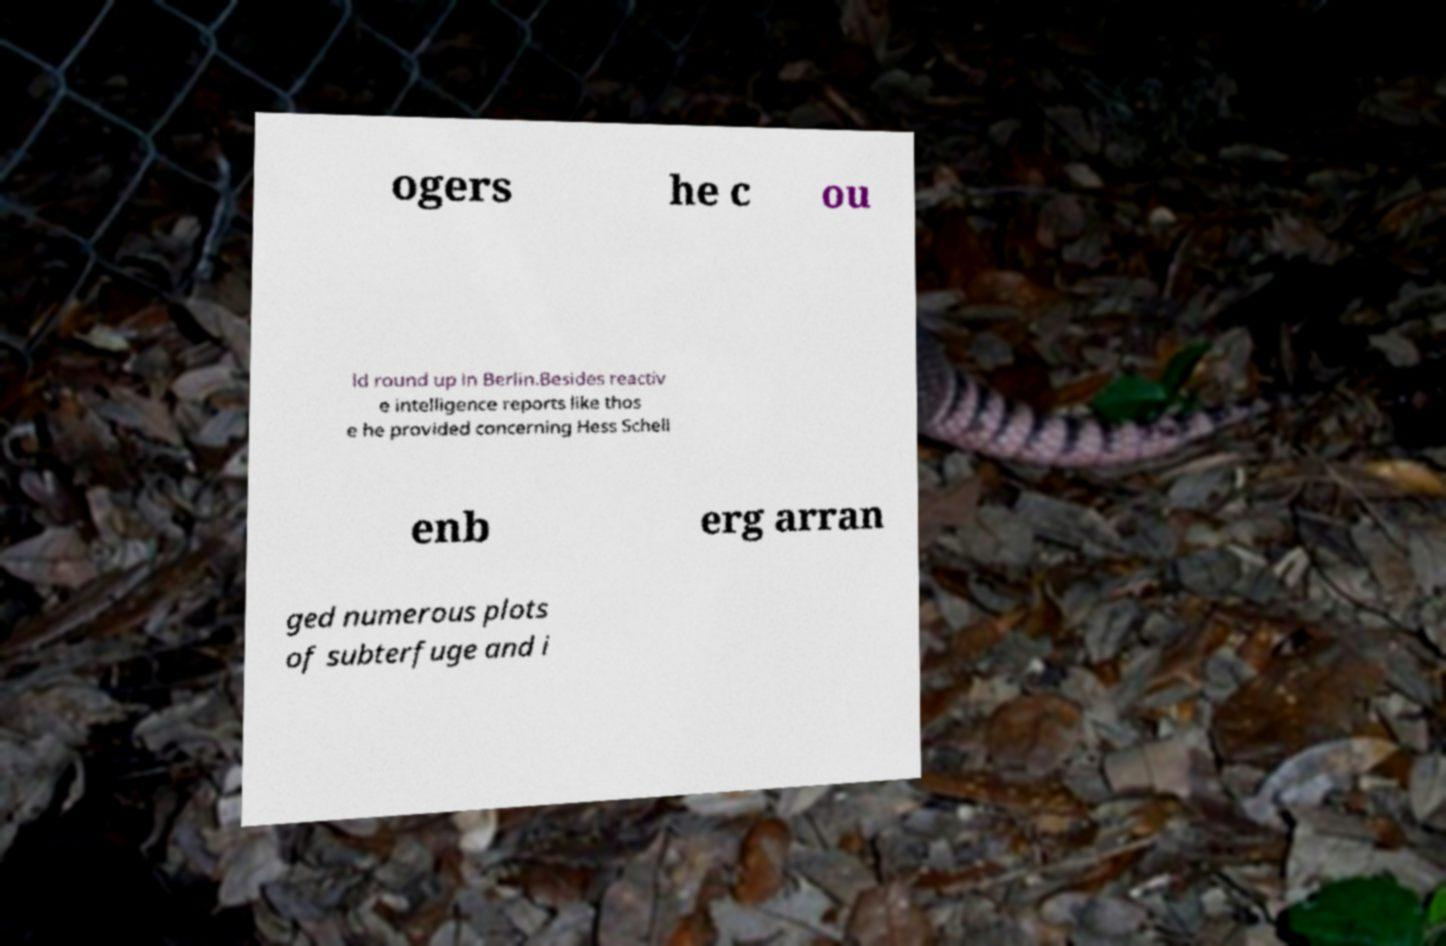There's text embedded in this image that I need extracted. Can you transcribe it verbatim? ogers he c ou ld round up in Berlin.Besides reactiv e intelligence reports like thos e he provided concerning Hess Schell enb erg arran ged numerous plots of subterfuge and i 